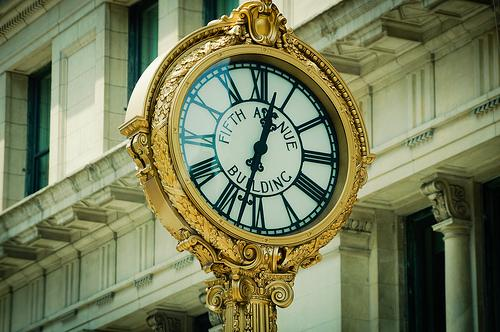Outline the principal subject and its location in the image. An intricately designed golden clock on a pole in front of a white building. Detail the central object in the image and its features. An ornate gold clock with roman numerals, black hands, and elegant writing on a white building's facade. Mention the most prominent aspect of the image. A gold clock with black roman numerals on a white building. Briefly describe the facade of the building in the image. A white building with ornate pillars and a gold clock attached to the front. Illustrate the architecture surrounding the main object of the image. A stately, white building with three windows up top and ornate pillars surrounding a golden clock. Concisely represent the clock, its design, and its place in the image. An elegantly designed gold clock with black roman numerals, situated on a pole in front of a white building. Highlight the clock's design elements in the image. A gold-framed clock with black roman numerals and hands, and white face on a pole. Characterize the appearance of the main object and its setting in the image. An ornate gold clock set against the backdrop of a sophisticated white building. Summarize the key components of the clock and the image's background. A decorative clock with a golden frame and roman numerals, positioned in front of a stately white building. Describe the visual elements of the clock in the image. The clock features a golden frame, black roman numerals and hands, and is mounted on a pole in front of a building. 